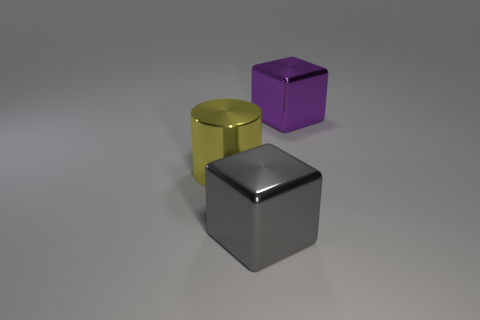Can you describe the shapes and colors of the objects in the image? Certainly! There are three objects: a gray cube, a metallic yellow cylinder, and a glossy purple cube. They are positioned on a plain surface with a subtle reflection of the objects on it. 